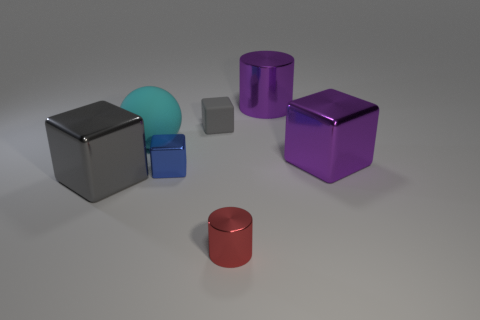Which objects in the image are reflective, and can you describe their shapes? The objects in the image that display reflective surfaces include the two cubes, one cylinder, and the two rectangular blocks. Their shapes, respectively, are a perfect cube, cylindrical with circular faces, and rectangular prisms. 